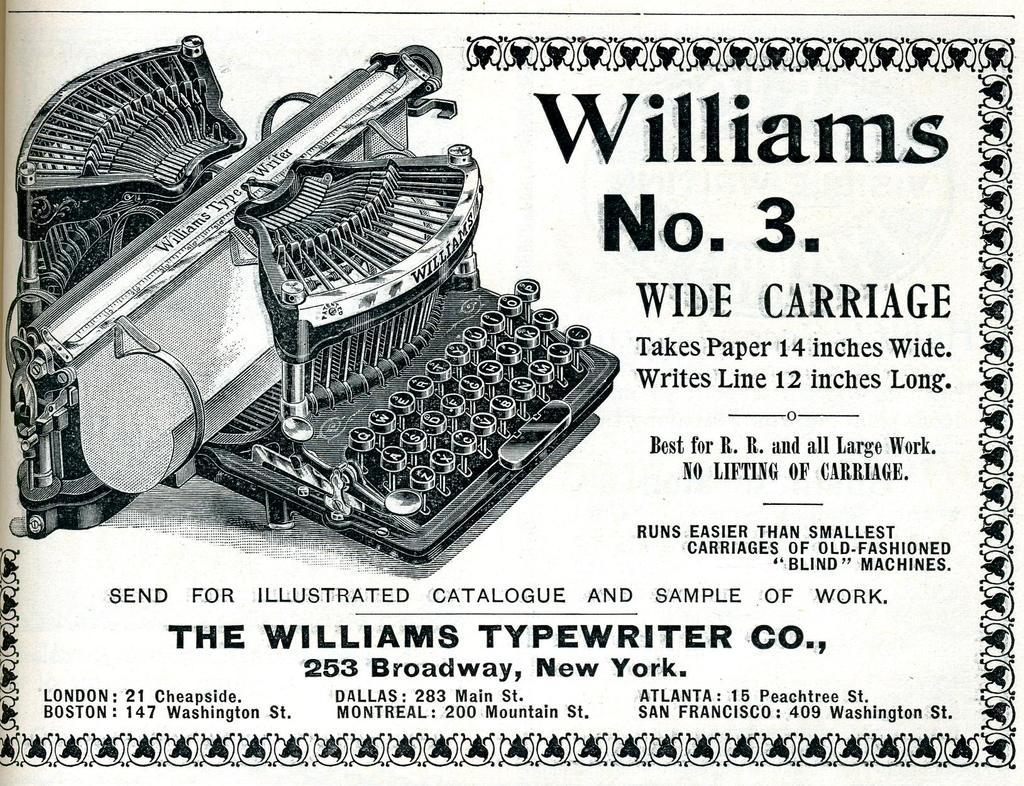Provide a one-sentence caption for the provided image. A Williams No.3 ad that is describing a typewriter company. 